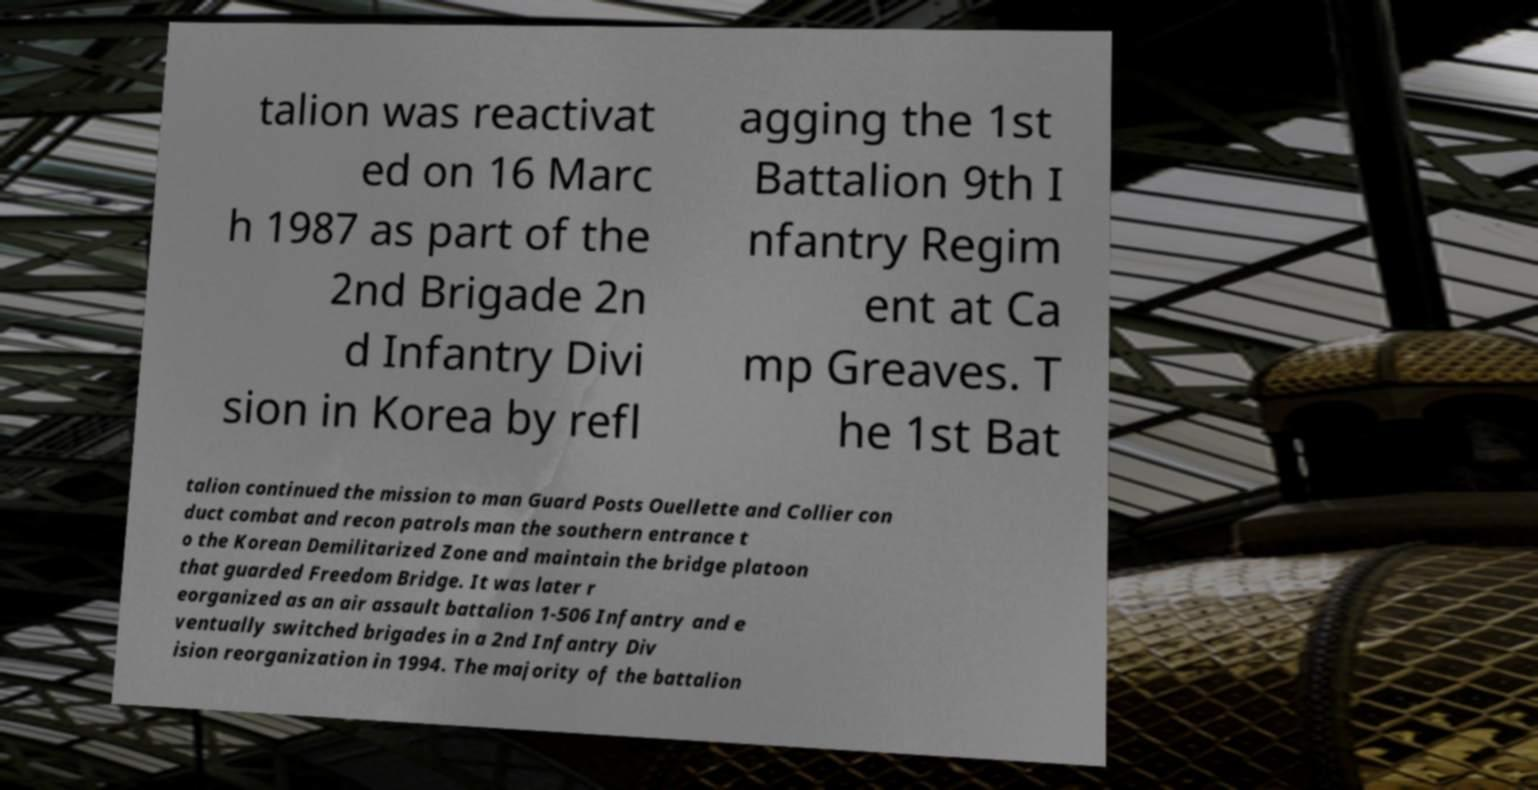Could you assist in decoding the text presented in this image and type it out clearly? talion was reactivat ed on 16 Marc h 1987 as part of the 2nd Brigade 2n d Infantry Divi sion in Korea by refl agging the 1st Battalion 9th I nfantry Regim ent at Ca mp Greaves. T he 1st Bat talion continued the mission to man Guard Posts Ouellette and Collier con duct combat and recon patrols man the southern entrance t o the Korean Demilitarized Zone and maintain the bridge platoon that guarded Freedom Bridge. It was later r eorganized as an air assault battalion 1-506 Infantry and e ventually switched brigades in a 2nd Infantry Div ision reorganization in 1994. The majority of the battalion 